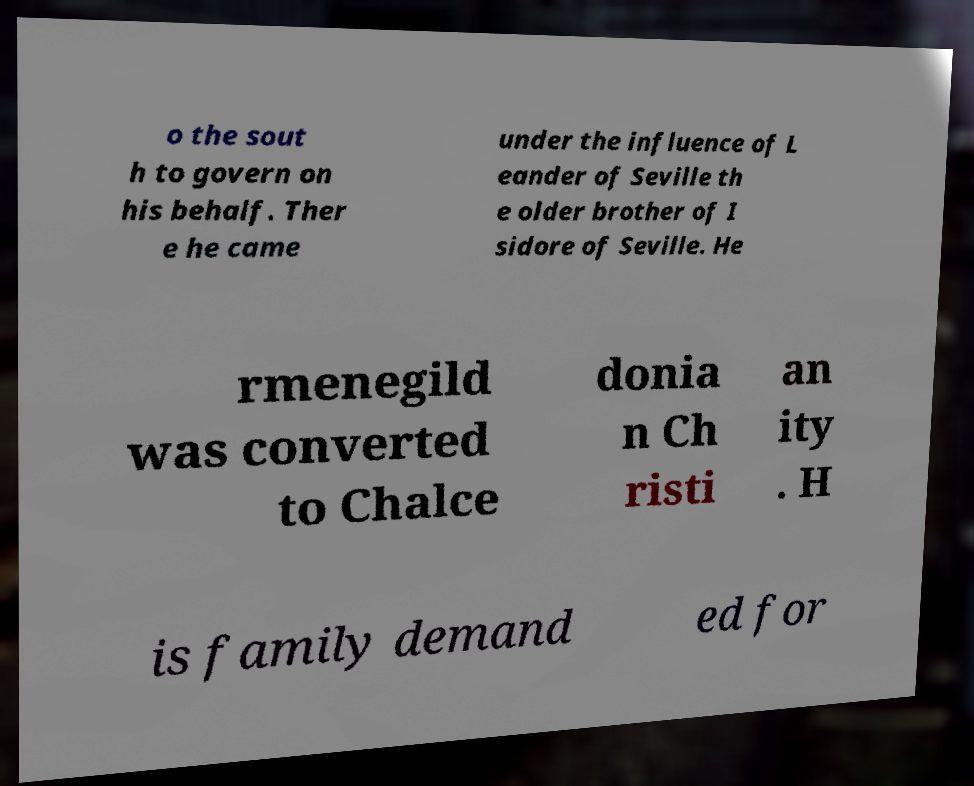There's text embedded in this image that I need extracted. Can you transcribe it verbatim? o the sout h to govern on his behalf. Ther e he came under the influence of L eander of Seville th e older brother of I sidore of Seville. He rmenegild was converted to Chalce donia n Ch risti an ity . H is family demand ed for 